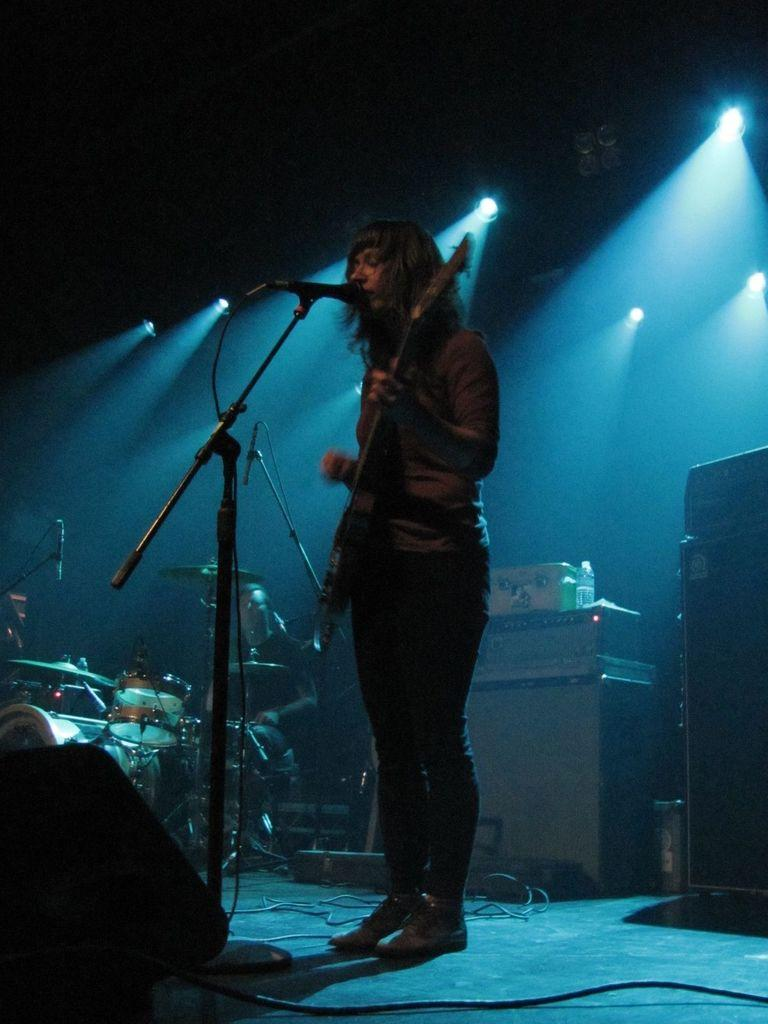Who is the main subject in the image? There is a man in the image. What is the man doing in the image? The man is standing and playing a guitar. What object is present in the image that is typically used for amplifying sound? There is a microphone in the image. What type of cracker is the man holding in the image? There is no cracker present in the image; the man is playing a guitar. 